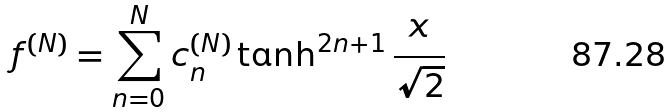Convert formula to latex. <formula><loc_0><loc_0><loc_500><loc_500>f ^ { ( N ) } = \sum _ { n = 0 } ^ { N } c _ { n } ^ { ( N ) } \tanh ^ { 2 n + 1 } \frac { x } { \sqrt { 2 } }</formula> 